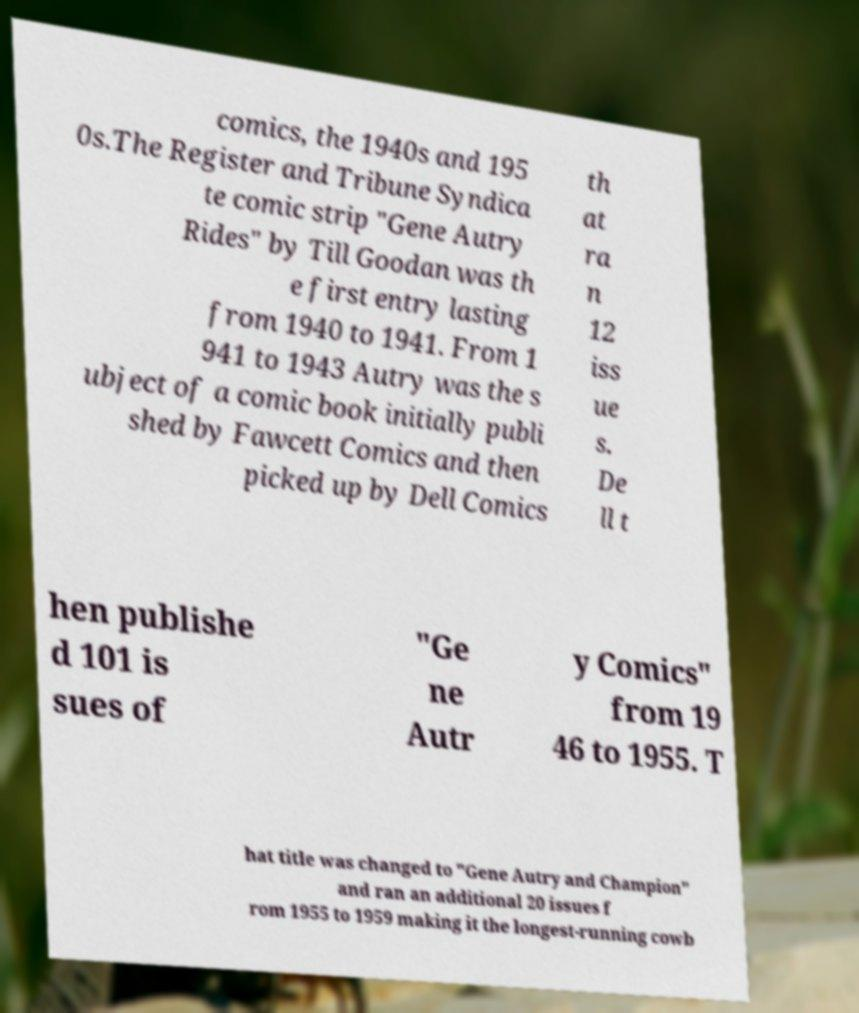There's text embedded in this image that I need extracted. Can you transcribe it verbatim? comics, the 1940s and 195 0s.The Register and Tribune Syndica te comic strip "Gene Autry Rides" by Till Goodan was th e first entry lasting from 1940 to 1941. From 1 941 to 1943 Autry was the s ubject of a comic book initially publi shed by Fawcett Comics and then picked up by Dell Comics th at ra n 12 iss ue s. De ll t hen publishe d 101 is sues of "Ge ne Autr y Comics" from 19 46 to 1955. T hat title was changed to "Gene Autry and Champion" and ran an additional 20 issues f rom 1955 to 1959 making it the longest-running cowb 